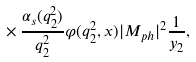Convert formula to latex. <formula><loc_0><loc_0><loc_500><loc_500>\times \, \frac { \alpha _ { s } ( q ^ { 2 } _ { 2 } ) } { q ^ { 2 } _ { 2 } } \varphi ( q ^ { 2 } _ { 2 } , x ) | M _ { p h } | ^ { 2 } \frac { 1 } { y _ { 2 } } ,</formula> 